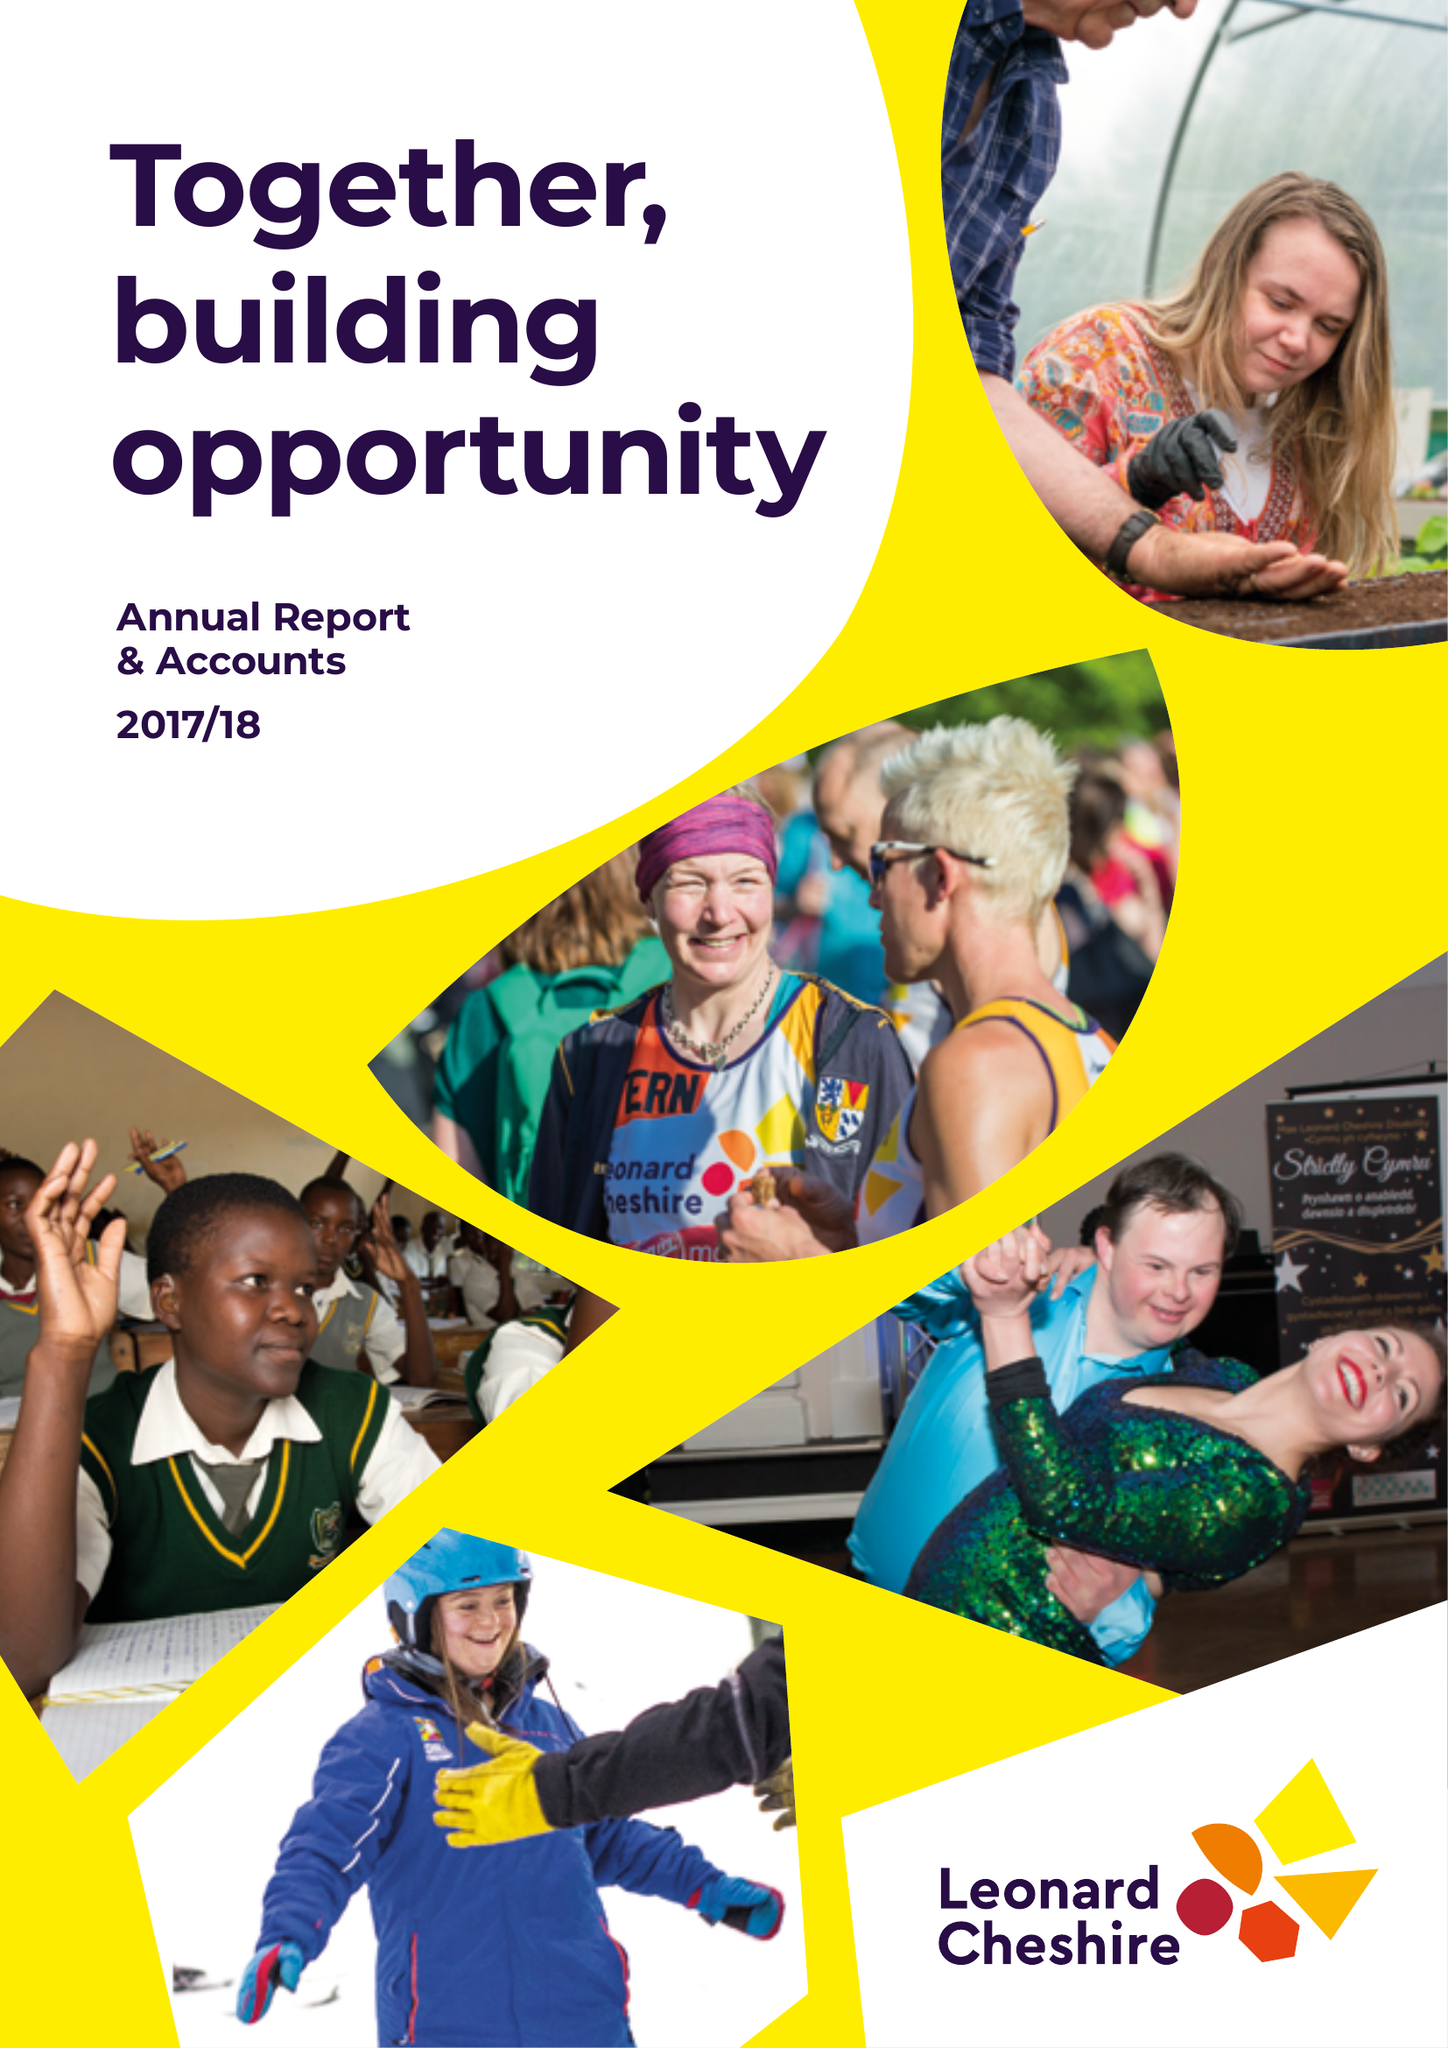What is the value for the charity_number?
Answer the question using a single word or phrase. 218186 